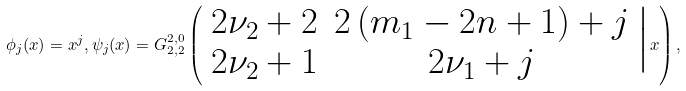<formula> <loc_0><loc_0><loc_500><loc_500>\phi _ { j } ( x ) = x ^ { j } , \psi _ { j } ( x ) = G _ { 2 , 2 } ^ { 2 , 0 } \left ( \begin{array} { c c } 2 \nu _ { 2 } + 2 & 2 \left ( m _ { 1 } - 2 n + 1 \right ) + j \\ 2 \nu _ { 2 } + 1 & 2 \nu _ { 1 } + j \end{array} \Big | x \right ) ,</formula> 